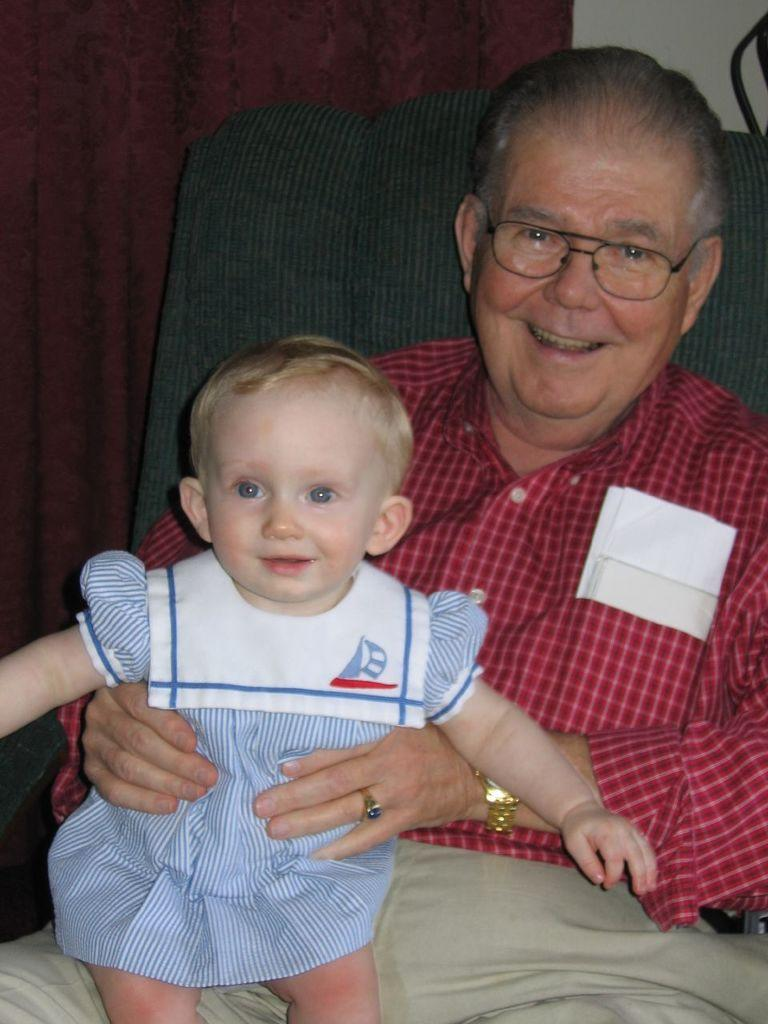Who is the main subject in the image? The main subject in the image is an old man. What is the old man wearing? The old man is wearing a red check shirt and cream-colored pants. What is the old man doing in the image? The old man is sitting on a chair and holding a baby. What is the baby wearing? The baby is wearing a blue and white striped dress. What can be seen in the background of the image? There is a wall in the background of the image. How many chickens are visible in the image? There are no chickens visible in the image. What type of truck can be seen in the background of the image? There is no truck present in the image. 